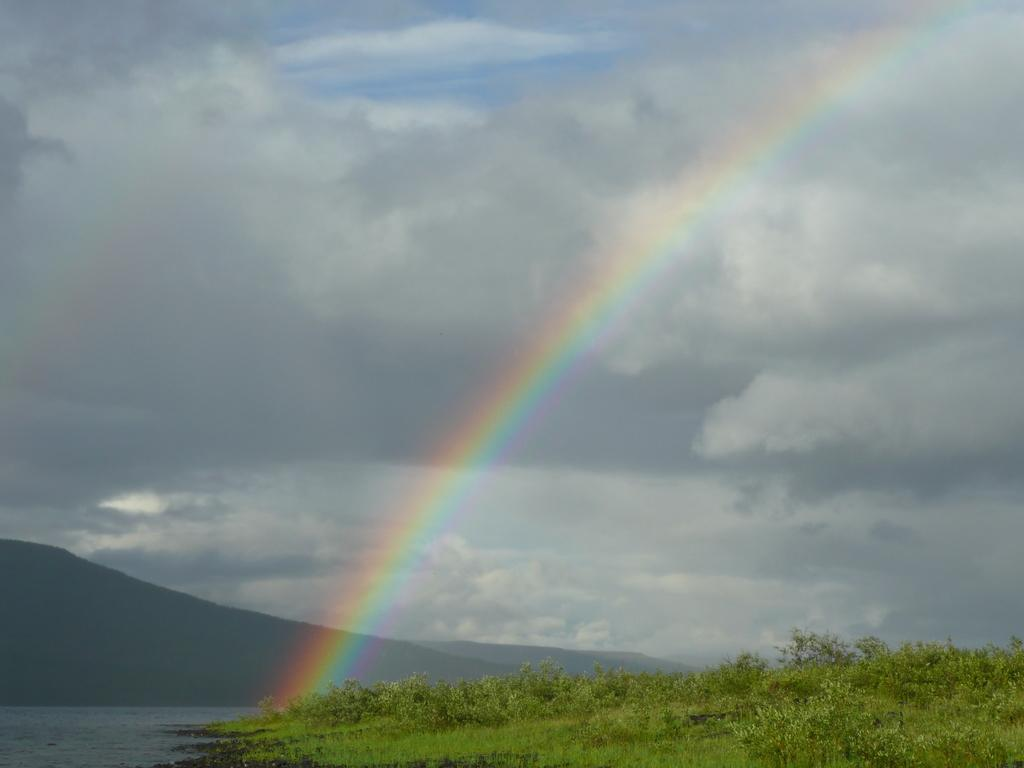What can be seen in the sky in the image? The sky with clouds is visible in the image. What natural phenomenon is present in the image? There is a rainbow in the image. What type of landform can be seen in the image? There are hills in the image. What is the body of water visible in the image called? The body of water visible in the image is not specified, so it cannot be named. What is the surface on which the hills and water are located? The ground is visible in the image. What type of vegetation is present in the image? Plants are present in the image. How many bees can be seen flying around the rainbow in the image? There are no bees visible in the image. What type of horse is depicted grazing on the hills in the image? There are no horses present in the image. 